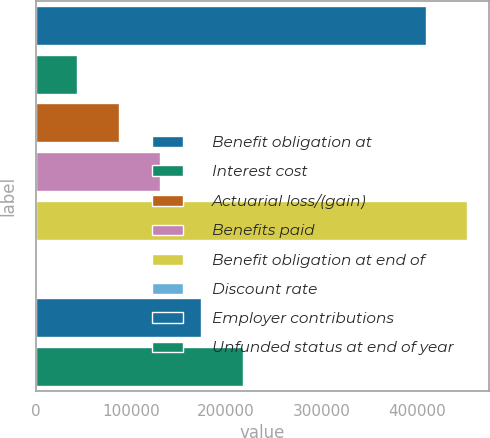Convert chart. <chart><loc_0><loc_0><loc_500><loc_500><bar_chart><fcel>Benefit obligation at<fcel>Interest cost<fcel>Actuarial loss/(gain)<fcel>Benefits paid<fcel>Benefit obligation at end of<fcel>Discount rate<fcel>Employer contributions<fcel>Unfunded status at end of year<nl><fcel>409470<fcel>43473.4<fcel>86941.8<fcel>130410<fcel>452938<fcel>4.98<fcel>173879<fcel>217347<nl></chart> 